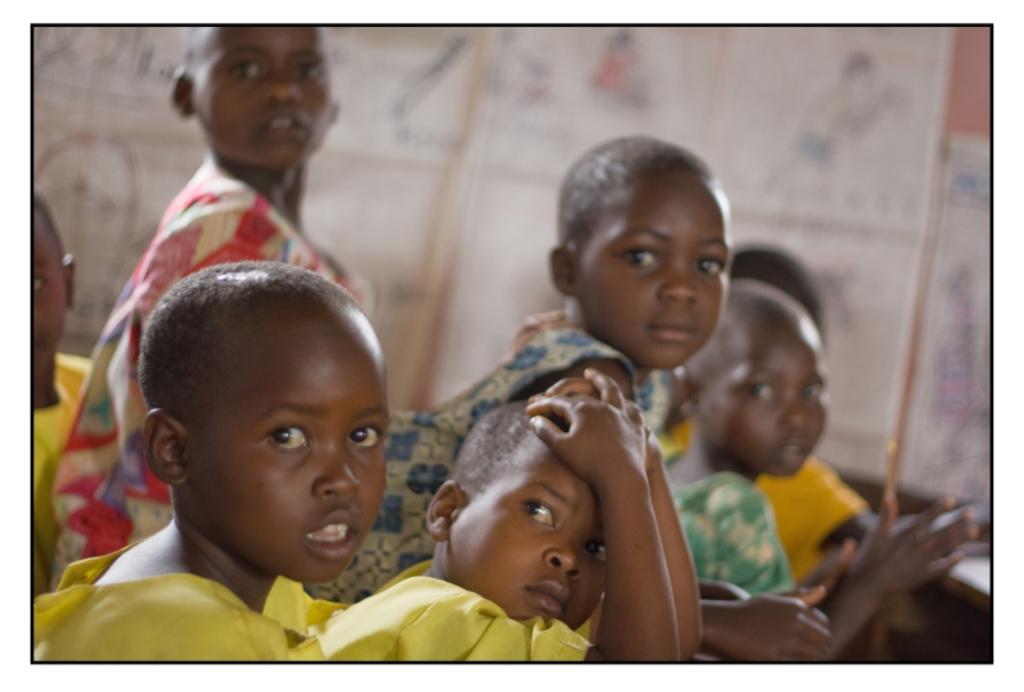Could you give a brief overview of what you see in this image? In this image I can see group of people, some are sitting and some are standing. In front the person is wearing yellow color dress and I can see blurred background. 